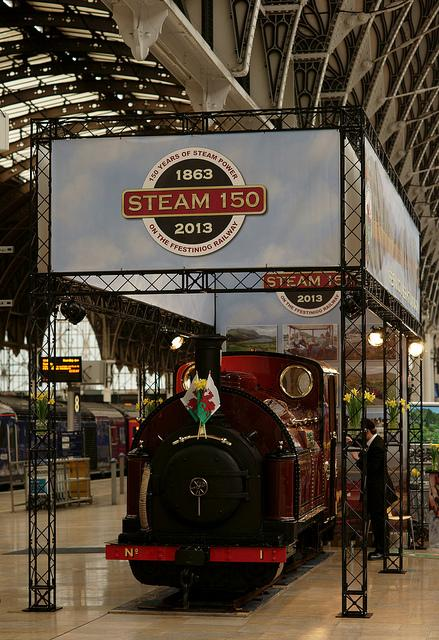What operation should be done with the numbers to arrive at the years of steam power?

Choices:
A) division
B) multiplication
C) subtraction
D) addition subtraction 